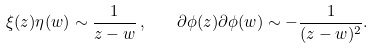<formula> <loc_0><loc_0><loc_500><loc_500>\xi ( z ) \eta ( w ) \sim \frac { 1 } { z - w } \, , \quad \partial \phi ( z ) \partial \phi ( w ) \sim - \frac { 1 } { ( z - w ) ^ { 2 } } .</formula> 